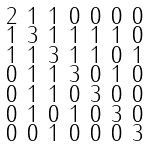Convert formula to latex. <formula><loc_0><loc_0><loc_500><loc_500>\begin{smallmatrix} 2 & 1 & 1 & 0 & 0 & 0 & 0 \\ 1 & 3 & 1 & 1 & 1 & 1 & 0 \\ 1 & 1 & 3 & 1 & 1 & 0 & 1 \\ 0 & 1 & 1 & 3 & 0 & 1 & 0 \\ 0 & 1 & 1 & 0 & 3 & 0 & 0 \\ 0 & 1 & 0 & 1 & 0 & 3 & 0 \\ 0 & 0 & 1 & 0 & 0 & 0 & 3 \end{smallmatrix}</formula> 